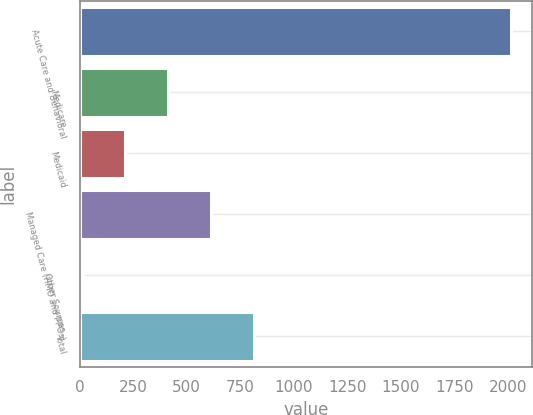Convert chart to OTSL. <chart><loc_0><loc_0><loc_500><loc_500><bar_chart><fcel>Acute Care and Behavioral<fcel>Medicare<fcel>Medicaid<fcel>Managed Care (HMO and PPOs)<fcel>Other Sources<fcel>Total<nl><fcel>2014<fcel>414<fcel>214<fcel>614<fcel>14<fcel>814<nl></chart> 